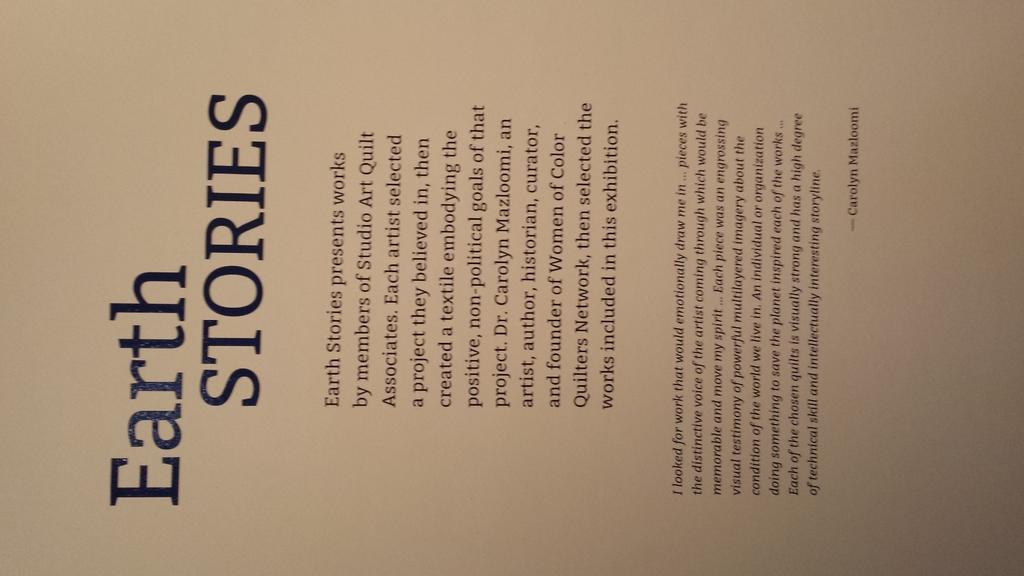<image>
Give a short and clear explanation of the subsequent image. The front page  from an old book titled Earth Stories in large font with 2 paragraphs below it in a smaller font. 